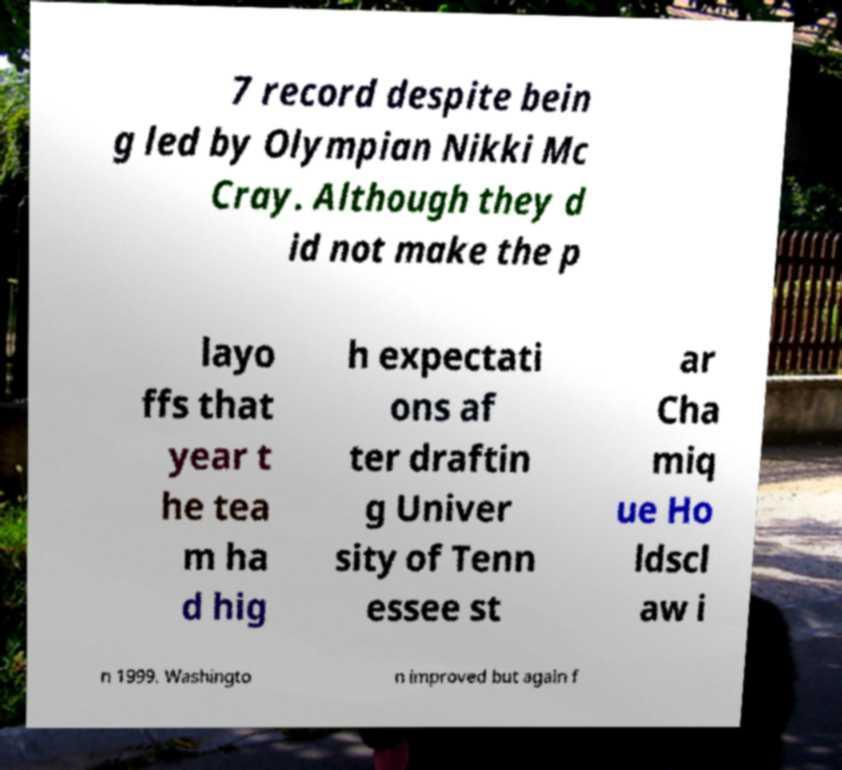Can you read and provide the text displayed in the image?This photo seems to have some interesting text. Can you extract and type it out for me? 7 record despite bein g led by Olympian Nikki Mc Cray. Although they d id not make the p layo ffs that year t he tea m ha d hig h expectati ons af ter draftin g Univer sity of Tenn essee st ar Cha miq ue Ho ldscl aw i n 1999. Washingto n improved but again f 